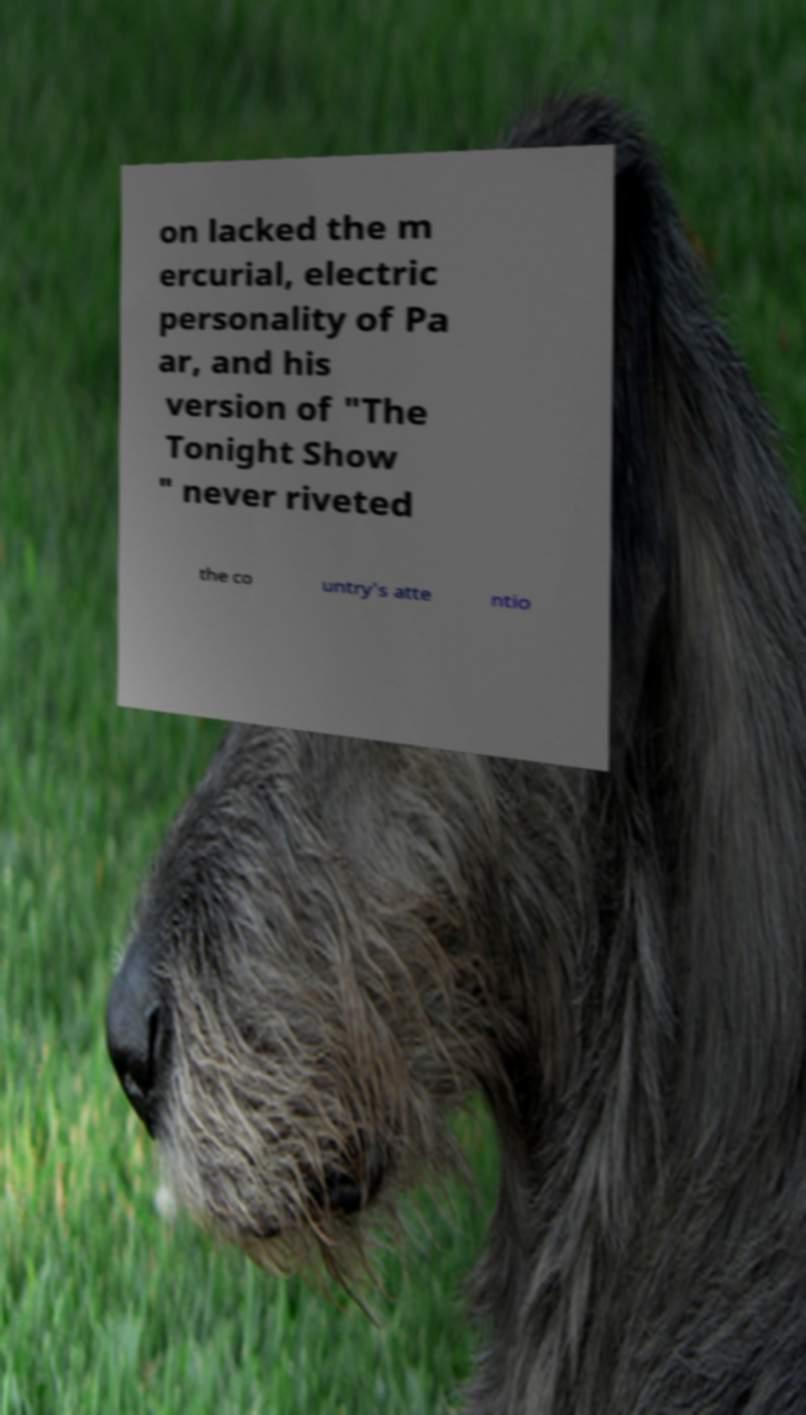What messages or text are displayed in this image? I need them in a readable, typed format. on lacked the m ercurial, electric personality of Pa ar, and his version of "The Tonight Show " never riveted the co untry's atte ntio 